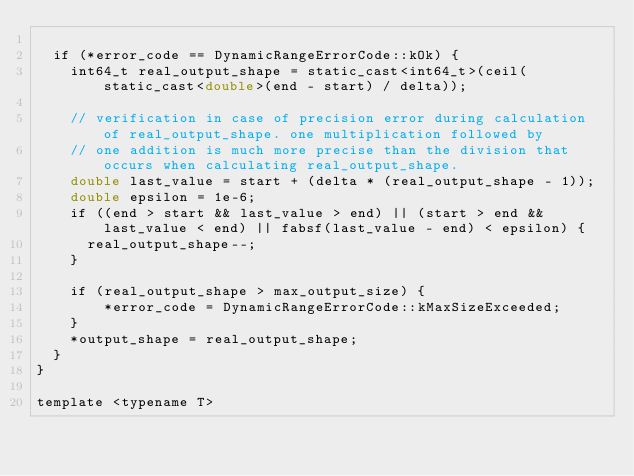Convert code to text. <code><loc_0><loc_0><loc_500><loc_500><_Cuda_>
  if (*error_code == DynamicRangeErrorCode::kOk) {
    int64_t real_output_shape = static_cast<int64_t>(ceil(static_cast<double>(end - start) / delta));

    // verification in case of precision error during calculation of real_output_shape. one multiplication followed by
    // one addition is much more precise than the division that occurs when calculating real_output_shape.
    double last_value = start + (delta * (real_output_shape - 1));
    double epsilon = 1e-6;
    if ((end > start && last_value > end) || (start > end && last_value < end) || fabsf(last_value - end) < epsilon) {
      real_output_shape--;
    }

    if (real_output_shape > max_output_size) {
        *error_code = DynamicRangeErrorCode::kMaxSizeExceeded;
    }
    *output_shape = real_output_shape;
  }
}

template <typename T></code> 